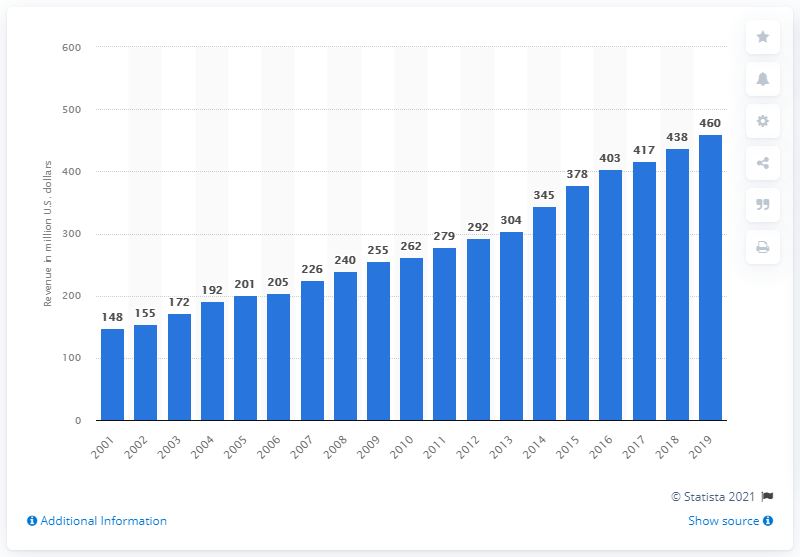Specify some key components in this picture. The revenue of the Baltimore Ravens in 2019 was approximately 460 million dollars. 